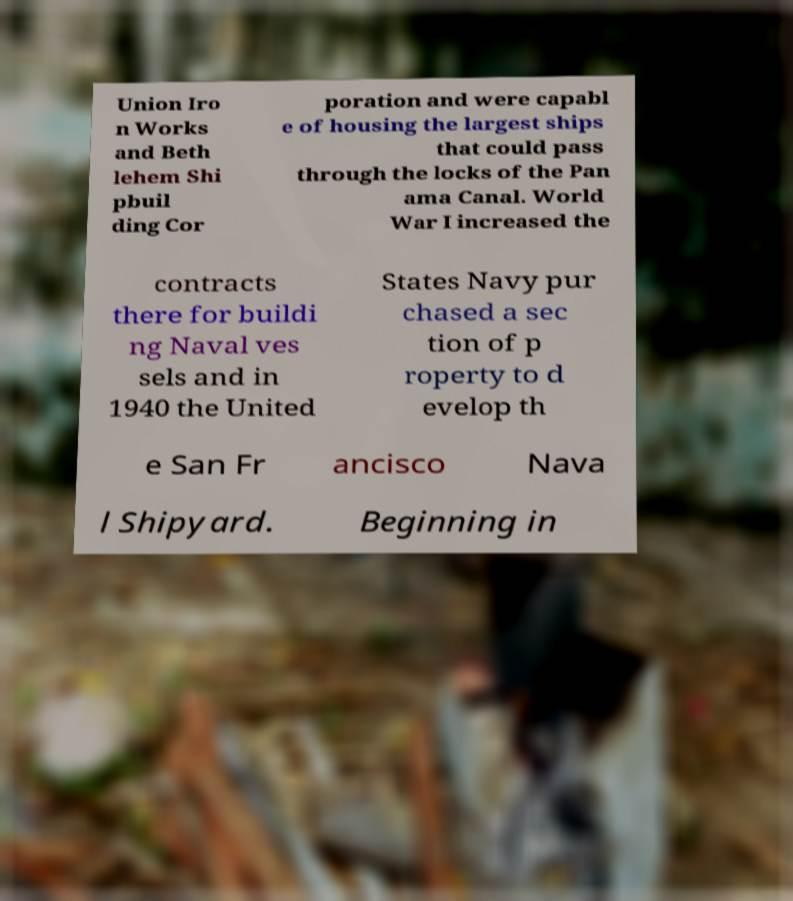Can you accurately transcribe the text from the provided image for me? Union Iro n Works and Beth lehem Shi pbuil ding Cor poration and were capabl e of housing the largest ships that could pass through the locks of the Pan ama Canal. World War I increased the contracts there for buildi ng Naval ves sels and in 1940 the United States Navy pur chased a sec tion of p roperty to d evelop th e San Fr ancisco Nava l Shipyard. Beginning in 